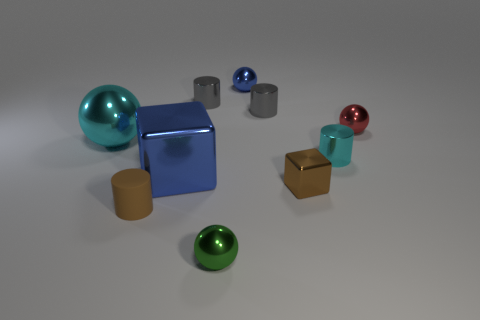Subtract all yellow blocks. How many gray cylinders are left? 2 Subtract 1 spheres. How many spheres are left? 3 Subtract all red balls. How many balls are left? 3 Subtract all metal cylinders. How many cylinders are left? 1 Subtract all green cylinders. Subtract all purple cubes. How many cylinders are left? 4 Subtract all cylinders. How many objects are left? 6 Subtract 1 red balls. How many objects are left? 9 Subtract all gray metallic things. Subtract all rubber things. How many objects are left? 7 Add 8 gray objects. How many gray objects are left? 10 Add 1 cyan things. How many cyan things exist? 3 